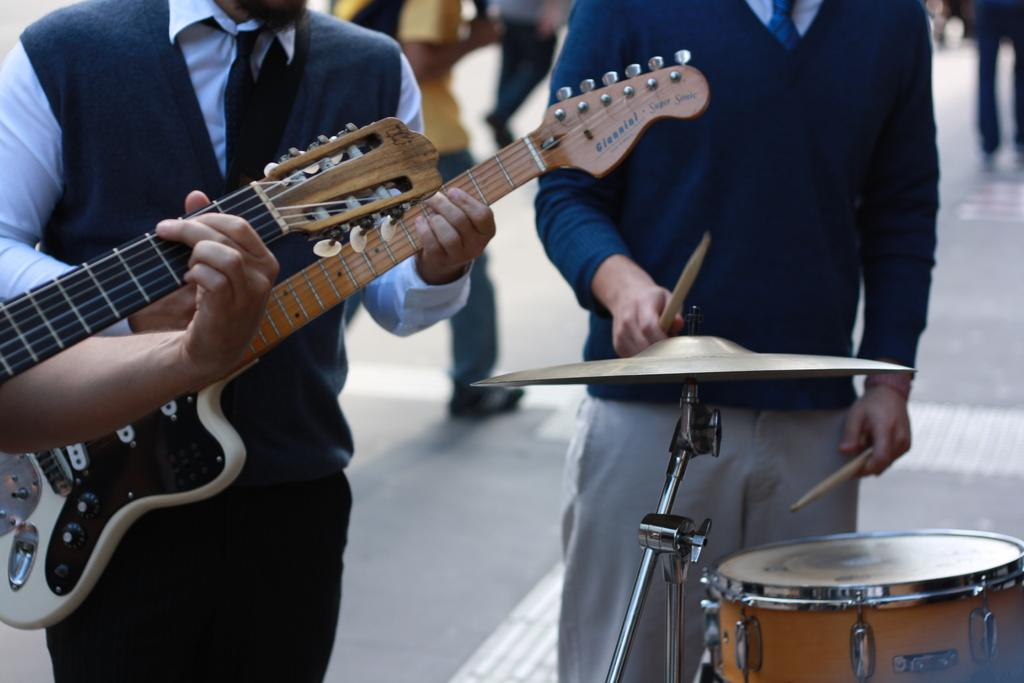What are the two persons in the image doing? The two persons in the image are playing musical instruments. What specific instruments are they playing? One person is playing a guitar, and the other person is playing a drum. Can you describe the background of the image? In the background of the image, there are persons walking on a road. What type of cloth is being washed in the image? There is no cloth or washing activity present in the image. Where is the house located in the image? There is no house mentioned or visible in the image. 